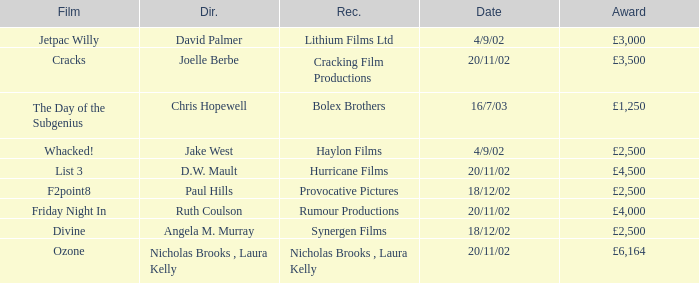Who directed a film for Cracking Film Productions? Joelle Berbe. 